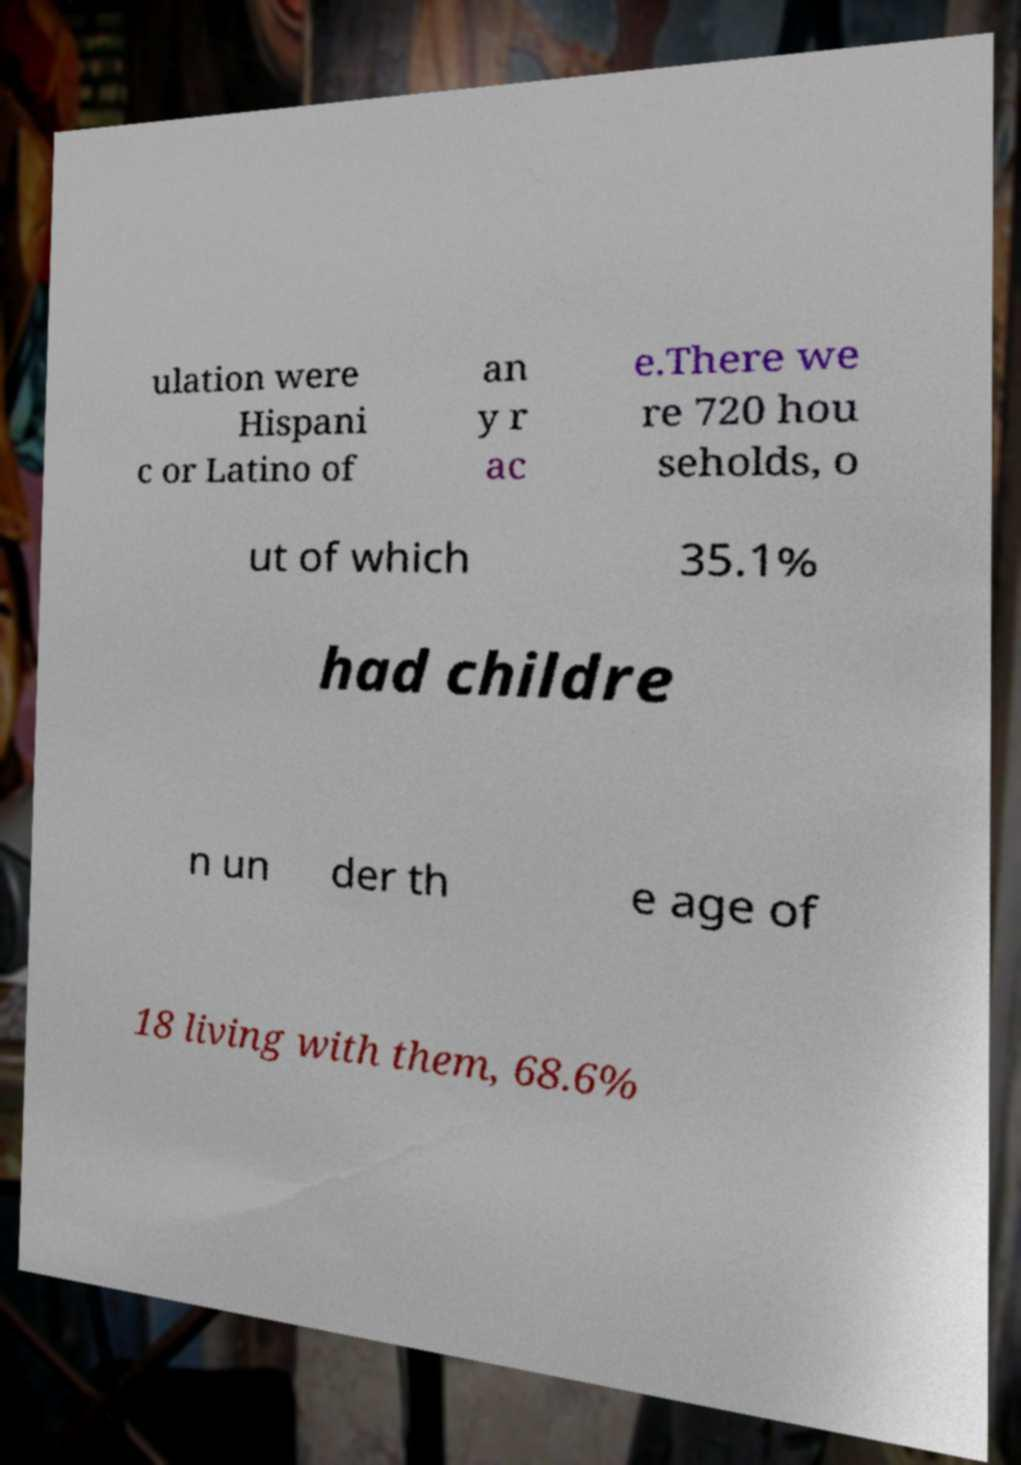I need the written content from this picture converted into text. Can you do that? ulation were Hispani c or Latino of an y r ac e.There we re 720 hou seholds, o ut of which 35.1% had childre n un der th e age of 18 living with them, 68.6% 